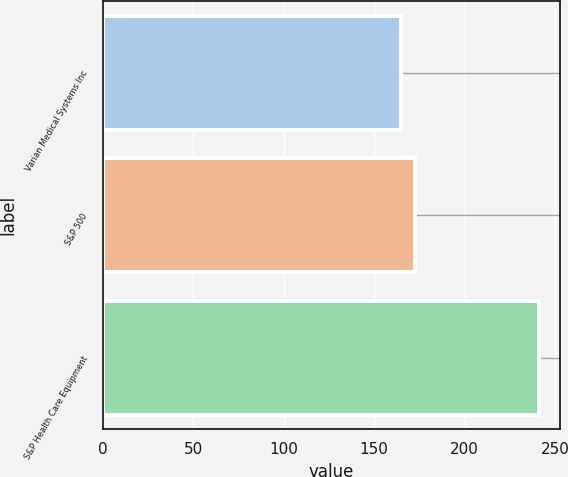<chart> <loc_0><loc_0><loc_500><loc_500><bar_chart><fcel>Varian Medical Systems Inc<fcel>S&P 500<fcel>S&P Health Care Equipment<nl><fcel>164.94<fcel>172.53<fcel>240.85<nl></chart> 